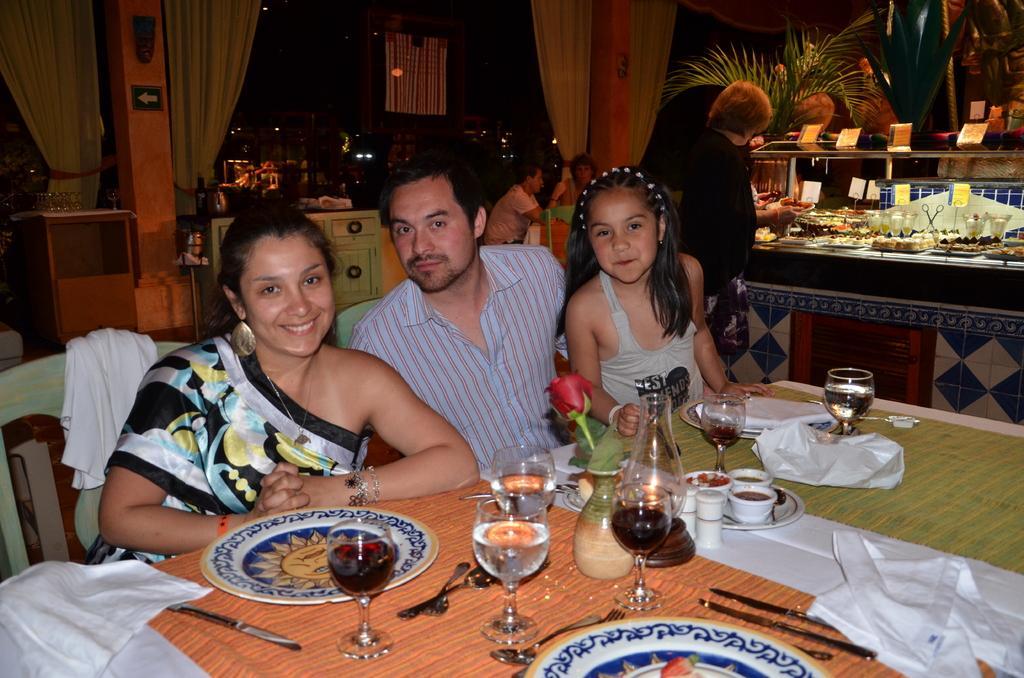Please provide a concise description of this image. In this image I can see the group of people sitting in-front of the table. On the table there is a plate,glass,spoons and the tissues. In the back there is a plant and the curtains. 